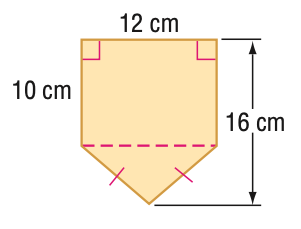Question: Find the area of the figure. Round to the nearest tenth if necessary.
Choices:
A. 36
B. 120
C. 156
D. 192
Answer with the letter. Answer: C 